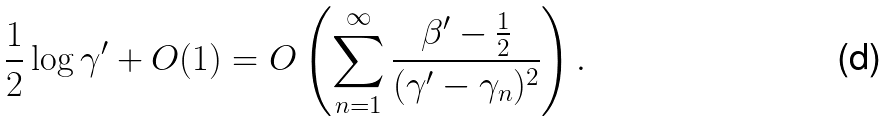<formula> <loc_0><loc_0><loc_500><loc_500>\frac { 1 } { 2 } \log \gamma ^ { \prime } + O ( 1 ) = O \left ( \sum _ { n = 1 } ^ { \infty } \frac { \beta ^ { \prime } - \frac { 1 } { 2 } } { ( \gamma ^ { \prime } - \gamma _ { n } ) ^ { 2 } } \right ) .</formula> 